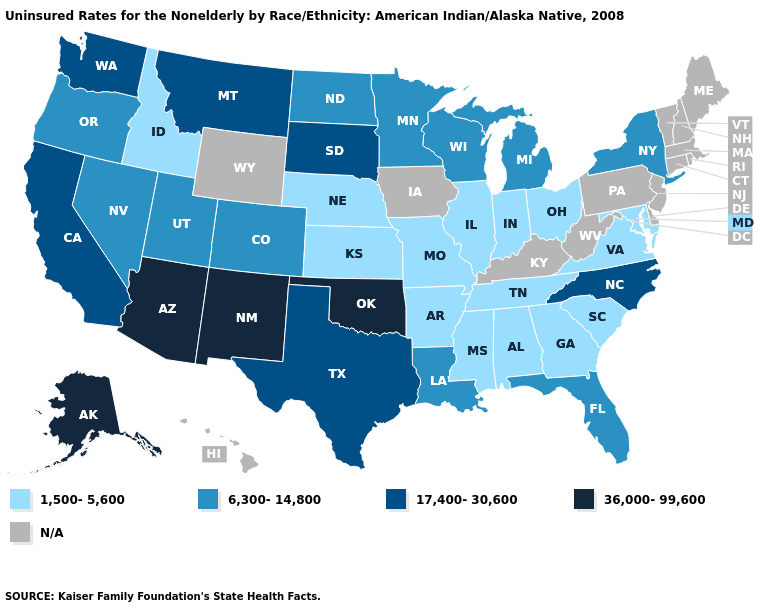What is the highest value in the South ?
Quick response, please. 36,000-99,600. Does California have the highest value in the USA?
Give a very brief answer. No. What is the value of Vermont?
Short answer required. N/A. What is the value of Alabama?
Keep it brief. 1,500-5,600. Among the states that border Virginia , which have the lowest value?
Keep it brief. Maryland, Tennessee. Name the states that have a value in the range 36,000-99,600?
Quick response, please. Alaska, Arizona, New Mexico, Oklahoma. What is the highest value in the USA?
Give a very brief answer. 36,000-99,600. What is the lowest value in states that border Illinois?
Give a very brief answer. 1,500-5,600. What is the lowest value in the MidWest?
Give a very brief answer. 1,500-5,600. Does Idaho have the lowest value in the West?
Answer briefly. Yes. What is the value of South Carolina?
Keep it brief. 1,500-5,600. Among the states that border New Jersey , which have the lowest value?
Write a very short answer. New York. 